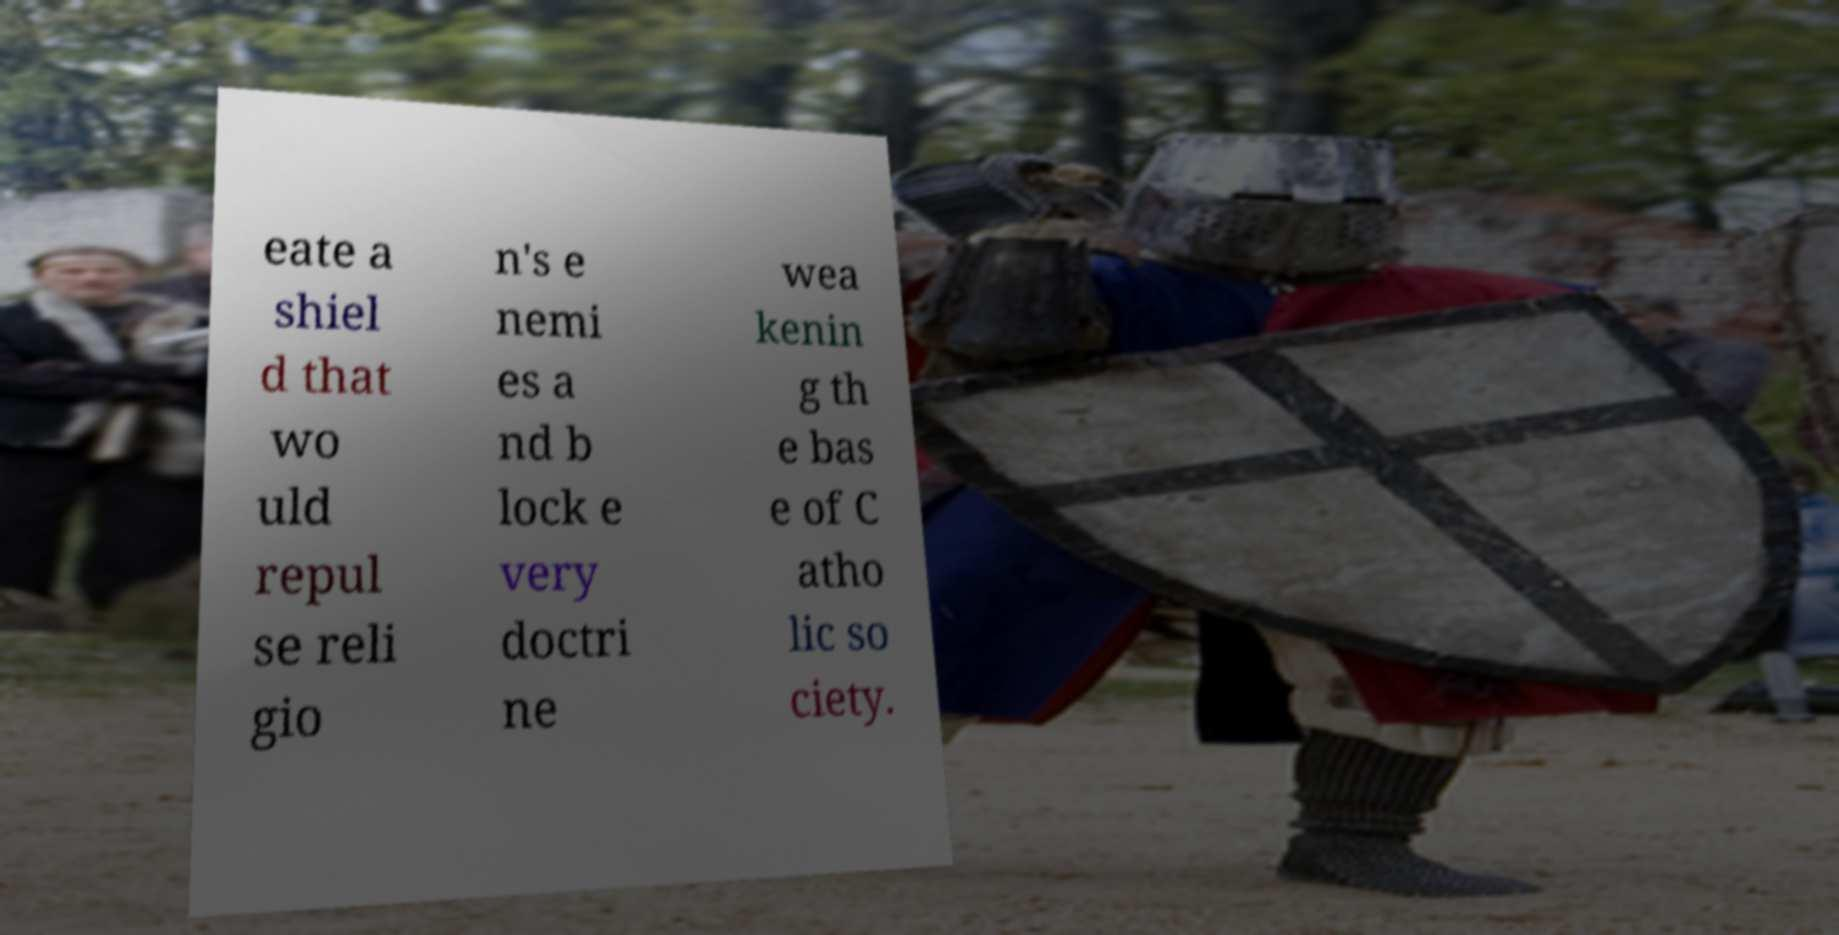What messages or text are displayed in this image? I need them in a readable, typed format. eate a shiel d that wo uld repul se reli gio n's e nemi es a nd b lock e very doctri ne wea kenin g th e bas e of C atho lic so ciety. 